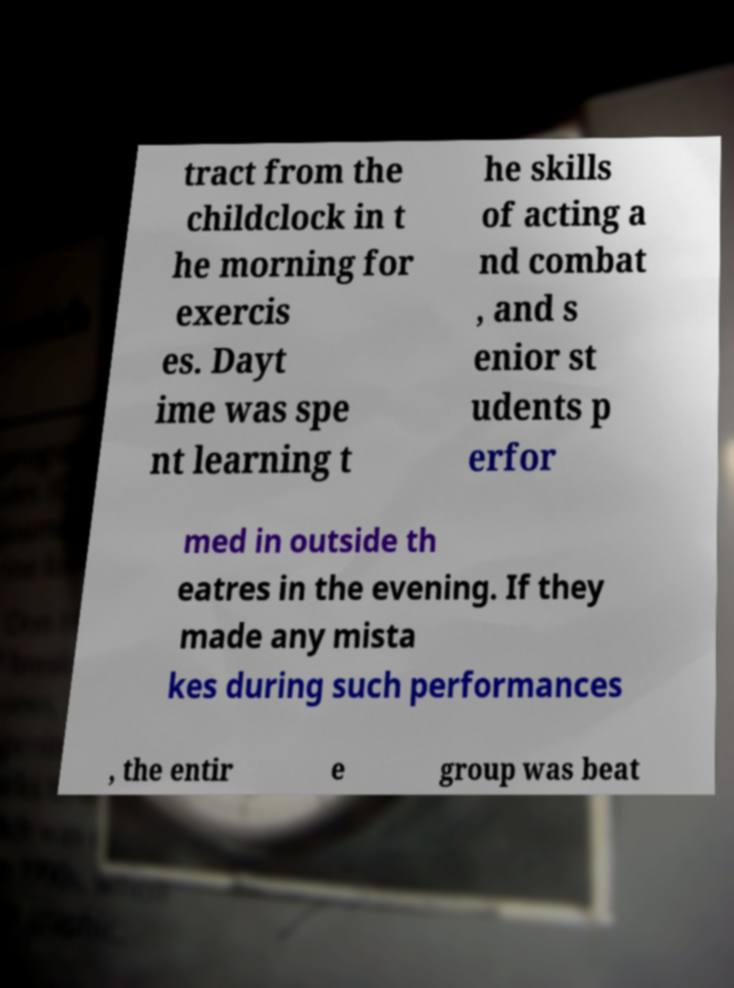Could you extract and type out the text from this image? tract from the childclock in t he morning for exercis es. Dayt ime was spe nt learning t he skills of acting a nd combat , and s enior st udents p erfor med in outside th eatres in the evening. If they made any mista kes during such performances , the entir e group was beat 